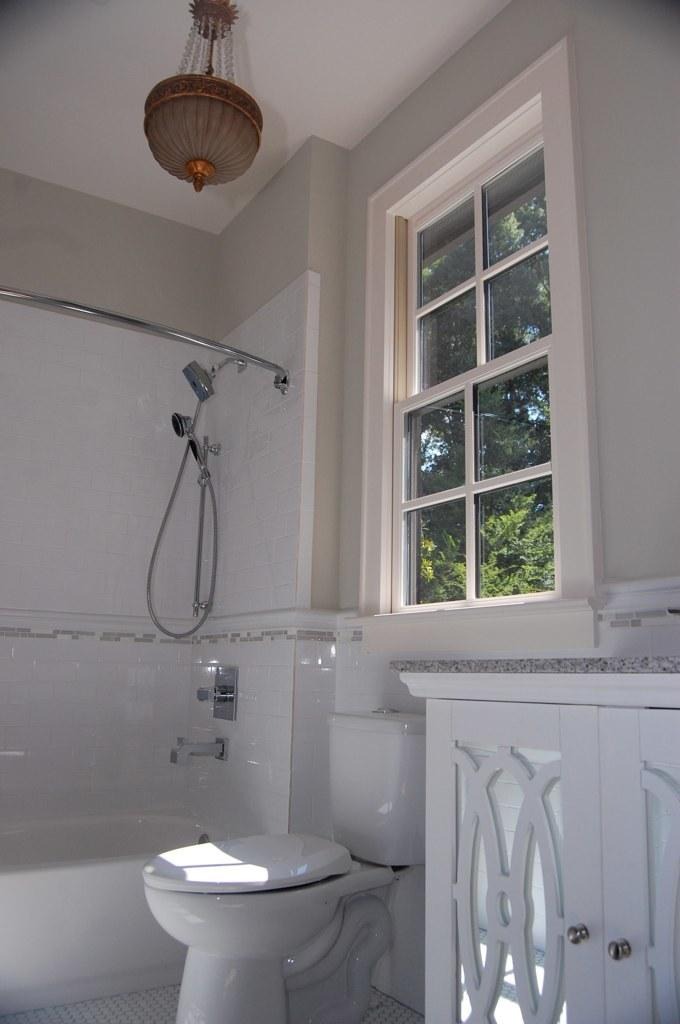What type of fixture is in the image? There is a toilet sink in the image. What is located on the right side of the image? There is a cupboard on the right side of the image. What can be seen in the background of the image? There is a window visible in the background of the image. What type of roof can be seen in the image? There is no roof visible in the image; it only shows a toilet sink, a cupboard, and a window. 